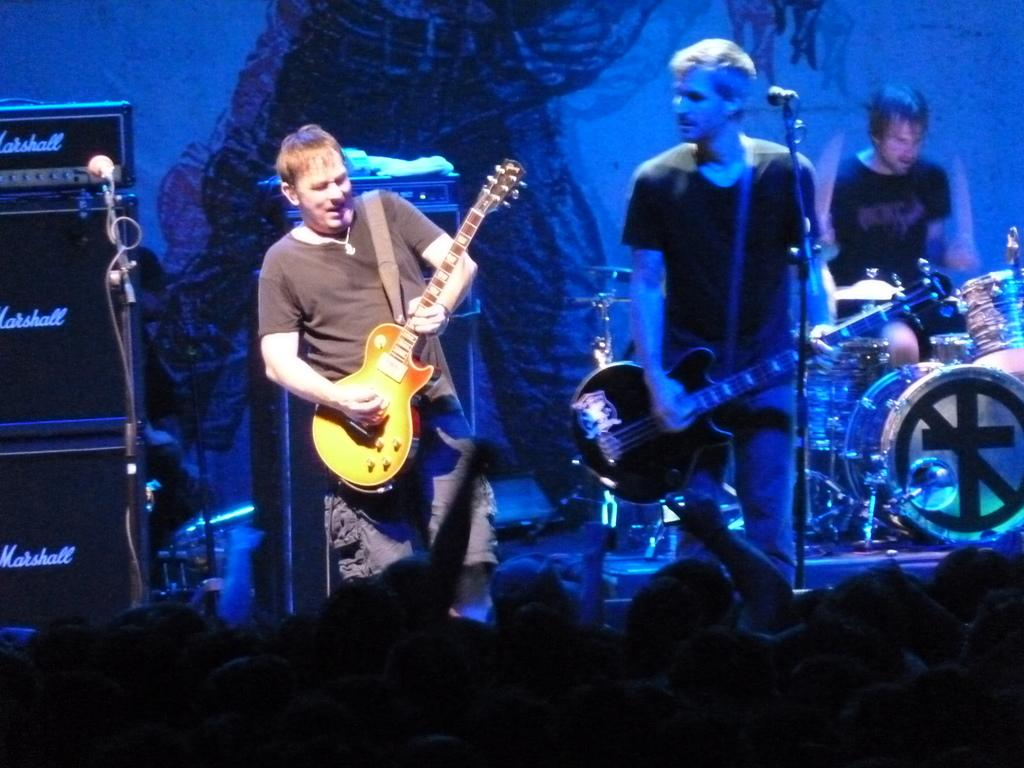What is happening in the image? There is a group of people in the image, and they are playing musical instruments. Where are the people located in the image? The people are standing on a stage. What can be seen in the background of the image? There is a blue color curtain in the background of the image. What might the people be using to amplify their voices? There is a microphone visible in the image. What type of soup is being served on the stage in the image? There is no soup present in the image; the people are playing musical instruments on a stage. What kind of rod can be seen holding up the curtain in the image? There is no rod visible in the image; only a blue color curtain is mentioned in the background. 